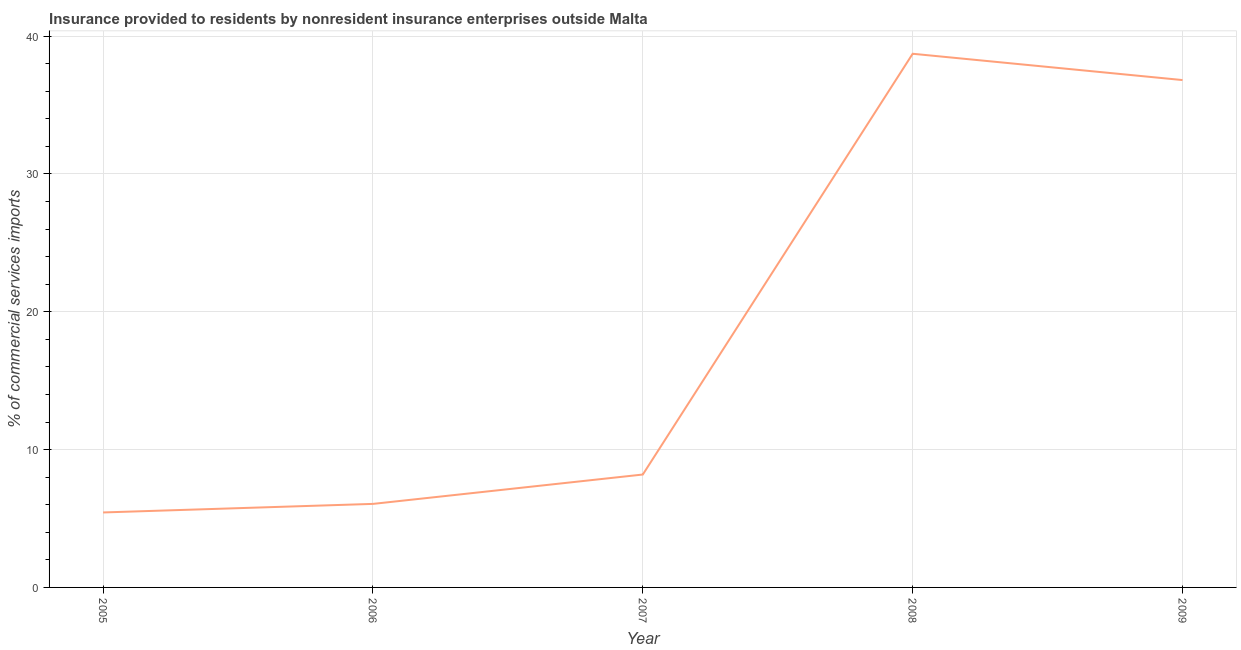What is the insurance provided by non-residents in 2007?
Your answer should be compact. 8.19. Across all years, what is the maximum insurance provided by non-residents?
Keep it short and to the point. 38.72. Across all years, what is the minimum insurance provided by non-residents?
Provide a short and direct response. 5.44. What is the sum of the insurance provided by non-residents?
Offer a terse response. 95.23. What is the difference between the insurance provided by non-residents in 2005 and 2007?
Provide a short and direct response. -2.75. What is the average insurance provided by non-residents per year?
Offer a terse response. 19.05. What is the median insurance provided by non-residents?
Provide a short and direct response. 8.19. What is the ratio of the insurance provided by non-residents in 2005 to that in 2009?
Provide a succinct answer. 0.15. Is the difference between the insurance provided by non-residents in 2005 and 2007 greater than the difference between any two years?
Offer a very short reply. No. What is the difference between the highest and the second highest insurance provided by non-residents?
Keep it short and to the point. 1.91. What is the difference between the highest and the lowest insurance provided by non-residents?
Your answer should be very brief. 33.28. Does the insurance provided by non-residents monotonically increase over the years?
Your answer should be very brief. No. What is the title of the graph?
Offer a terse response. Insurance provided to residents by nonresident insurance enterprises outside Malta. What is the label or title of the Y-axis?
Keep it short and to the point. % of commercial services imports. What is the % of commercial services imports of 2005?
Make the answer very short. 5.44. What is the % of commercial services imports of 2006?
Your answer should be very brief. 6.06. What is the % of commercial services imports of 2007?
Your answer should be compact. 8.19. What is the % of commercial services imports of 2008?
Provide a succinct answer. 38.72. What is the % of commercial services imports of 2009?
Keep it short and to the point. 36.82. What is the difference between the % of commercial services imports in 2005 and 2006?
Provide a short and direct response. -0.62. What is the difference between the % of commercial services imports in 2005 and 2007?
Offer a terse response. -2.75. What is the difference between the % of commercial services imports in 2005 and 2008?
Provide a succinct answer. -33.28. What is the difference between the % of commercial services imports in 2005 and 2009?
Give a very brief answer. -31.38. What is the difference between the % of commercial services imports in 2006 and 2007?
Your response must be concise. -2.13. What is the difference between the % of commercial services imports in 2006 and 2008?
Provide a short and direct response. -32.66. What is the difference between the % of commercial services imports in 2006 and 2009?
Keep it short and to the point. -30.75. What is the difference between the % of commercial services imports in 2007 and 2008?
Offer a terse response. -30.53. What is the difference between the % of commercial services imports in 2007 and 2009?
Ensure brevity in your answer.  -28.62. What is the difference between the % of commercial services imports in 2008 and 2009?
Give a very brief answer. 1.91. What is the ratio of the % of commercial services imports in 2005 to that in 2006?
Provide a short and direct response. 0.9. What is the ratio of the % of commercial services imports in 2005 to that in 2007?
Your answer should be compact. 0.66. What is the ratio of the % of commercial services imports in 2005 to that in 2008?
Offer a terse response. 0.14. What is the ratio of the % of commercial services imports in 2005 to that in 2009?
Your response must be concise. 0.15. What is the ratio of the % of commercial services imports in 2006 to that in 2007?
Your answer should be compact. 0.74. What is the ratio of the % of commercial services imports in 2006 to that in 2008?
Keep it short and to the point. 0.16. What is the ratio of the % of commercial services imports in 2006 to that in 2009?
Offer a very short reply. 0.17. What is the ratio of the % of commercial services imports in 2007 to that in 2008?
Offer a terse response. 0.21. What is the ratio of the % of commercial services imports in 2007 to that in 2009?
Give a very brief answer. 0.22. What is the ratio of the % of commercial services imports in 2008 to that in 2009?
Make the answer very short. 1.05. 